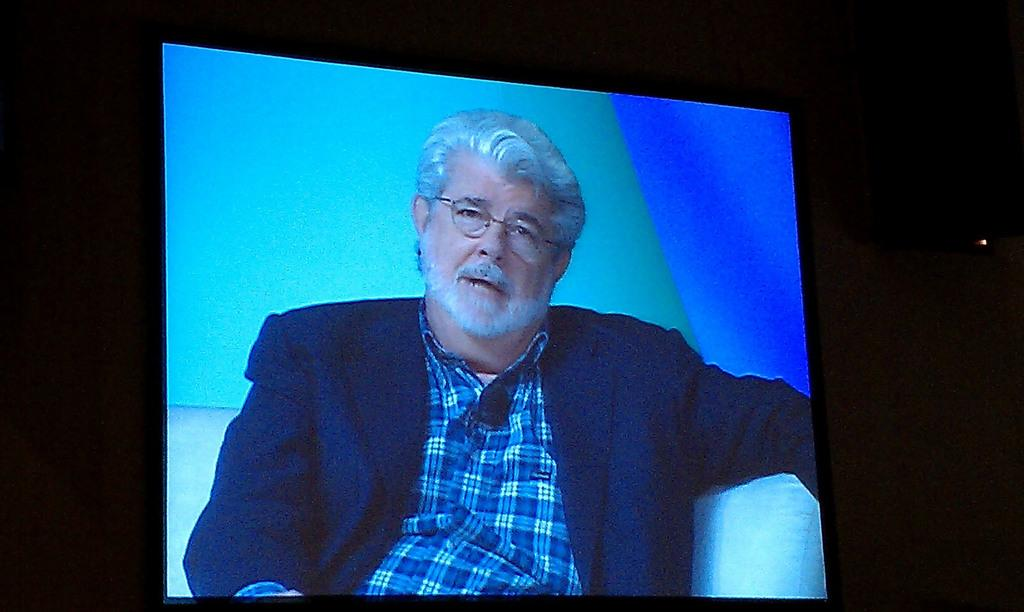What is the main object in the image? There is a screen in the image. What can be seen on the screen? A man is sitting on a couch in the screen. How would you describe the overall lighting in the image? The background of the image is dark. What type of note is the man holding in the image? There is no note present in the image; the man is sitting on a couch on the screen. 